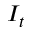Convert formula to latex. <formula><loc_0><loc_0><loc_500><loc_500>I _ { t }</formula> 